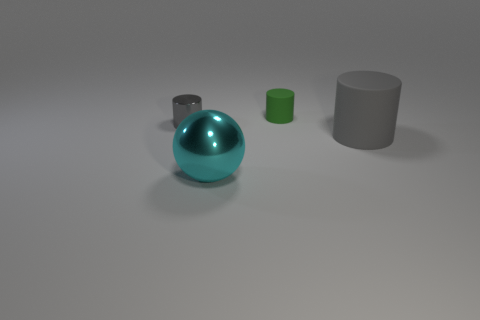Add 2 tiny rubber things. How many objects exist? 6 Subtract all spheres. How many objects are left? 3 Subtract 0 purple blocks. How many objects are left? 4 Subtract all big metal cylinders. Subtract all gray metallic things. How many objects are left? 3 Add 3 gray shiny things. How many gray shiny things are left? 4 Add 3 spheres. How many spheres exist? 4 